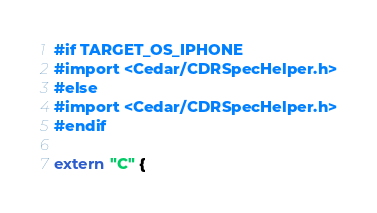<code> <loc_0><loc_0><loc_500><loc_500><_ObjectiveC_>#if TARGET_OS_IPHONE
#import <Cedar/CDRSpecHelper.h>
#else
#import <Cedar/CDRSpecHelper.h>
#endif

extern "C" {</code> 